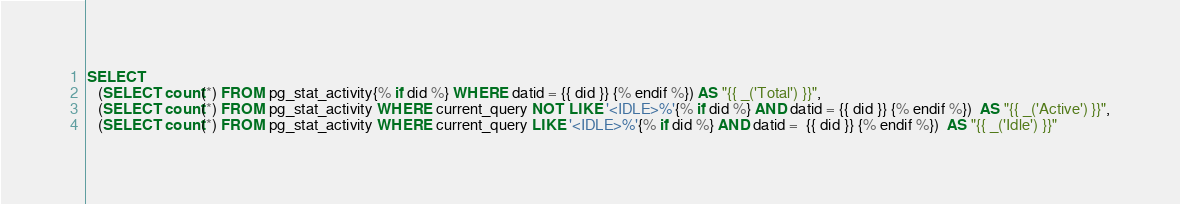Convert code to text. <code><loc_0><loc_0><loc_500><loc_500><_SQL_>SELECT
   (SELECT count(*) FROM pg_stat_activity{% if did %} WHERE datid = {{ did }} {% endif %}) AS "{{ _('Total') }}",
   (SELECT count(*) FROM pg_stat_activity WHERE current_query NOT LIKE '<IDLE>%'{% if did %} AND datid = {{ did }} {% endif %})  AS "{{ _('Active') }}",
   (SELECT count(*) FROM pg_stat_activity WHERE current_query LIKE '<IDLE>%'{% if did %} AND datid =  {{ did }} {% endif %})  AS "{{ _('Idle') }}"
</code> 